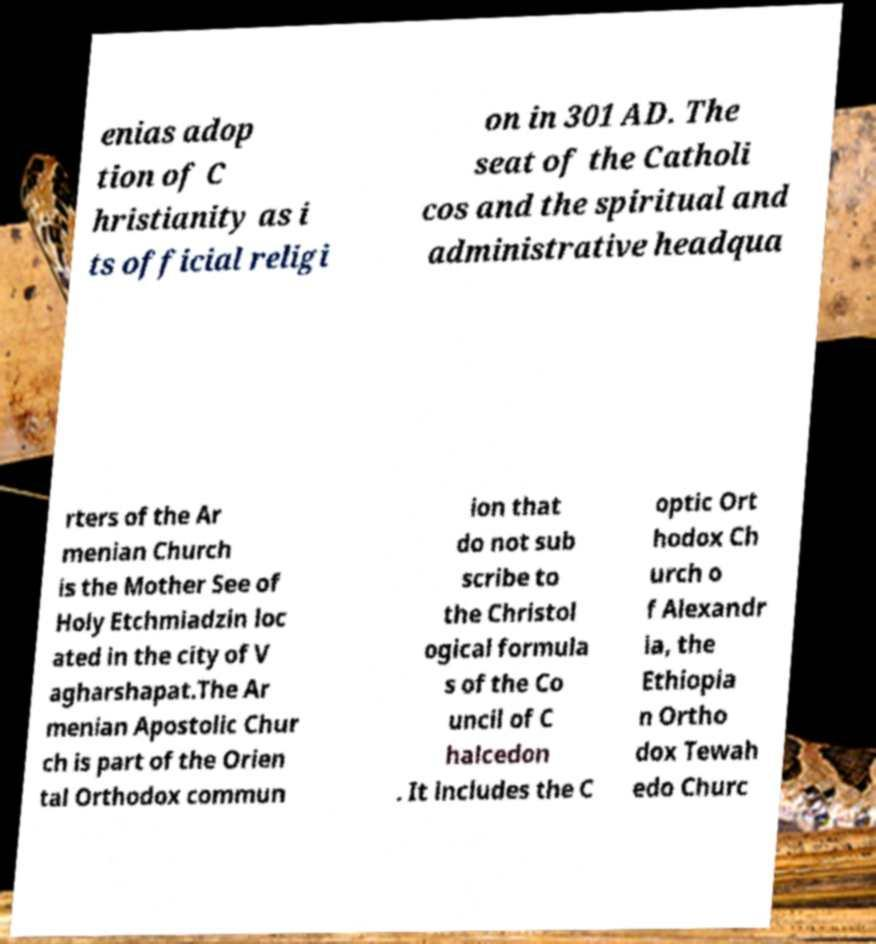There's text embedded in this image that I need extracted. Can you transcribe it verbatim? enias adop tion of C hristianity as i ts official religi on in 301 AD. The seat of the Catholi cos and the spiritual and administrative headqua rters of the Ar menian Church is the Mother See of Holy Etchmiadzin loc ated in the city of V agharshapat.The Ar menian Apostolic Chur ch is part of the Orien tal Orthodox commun ion that do not sub scribe to the Christol ogical formula s of the Co uncil of C halcedon . It includes the C optic Ort hodox Ch urch o f Alexandr ia, the Ethiopia n Ortho dox Tewah edo Churc 